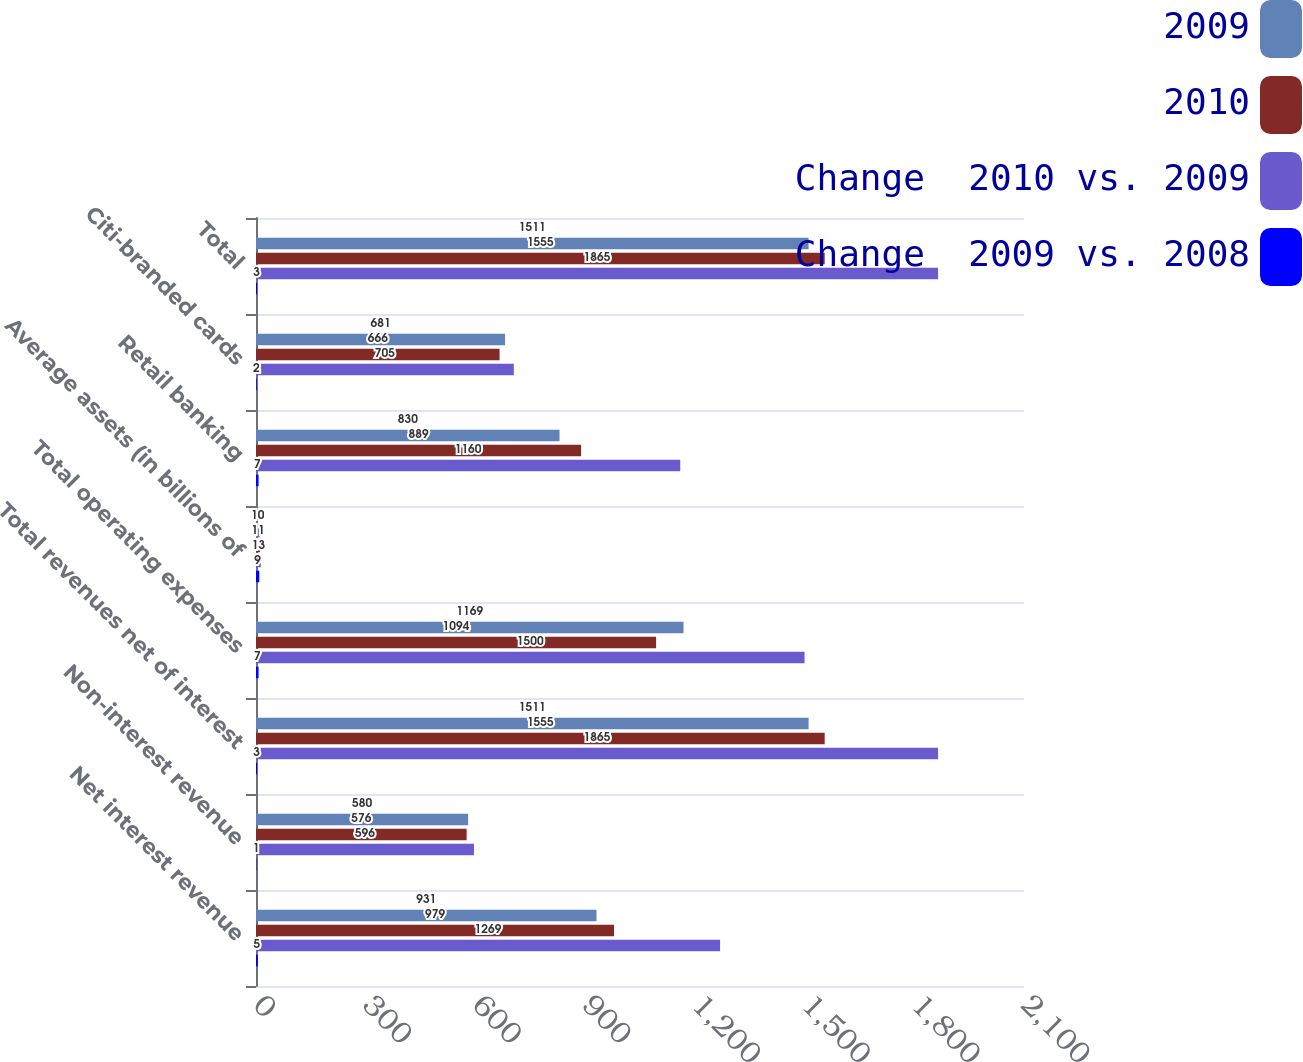Convert chart. <chart><loc_0><loc_0><loc_500><loc_500><stacked_bar_chart><ecel><fcel>Net interest revenue<fcel>Non-interest revenue<fcel>Total revenues net of interest<fcel>Total operating expenses<fcel>Average assets (in billions of<fcel>Retail banking<fcel>Citi-branded cards<fcel>Total<nl><fcel>2009<fcel>931<fcel>580<fcel>1511<fcel>1169<fcel>10<fcel>830<fcel>681<fcel>1511<nl><fcel>2010<fcel>979<fcel>576<fcel>1555<fcel>1094<fcel>11<fcel>889<fcel>666<fcel>1555<nl><fcel>Change  2010 vs. 2009<fcel>1269<fcel>596<fcel>1865<fcel>1500<fcel>13<fcel>1160<fcel>705<fcel>1865<nl><fcel>Change  2009 vs. 2008<fcel>5<fcel>1<fcel>3<fcel>7<fcel>9<fcel>7<fcel>2<fcel>3<nl></chart> 